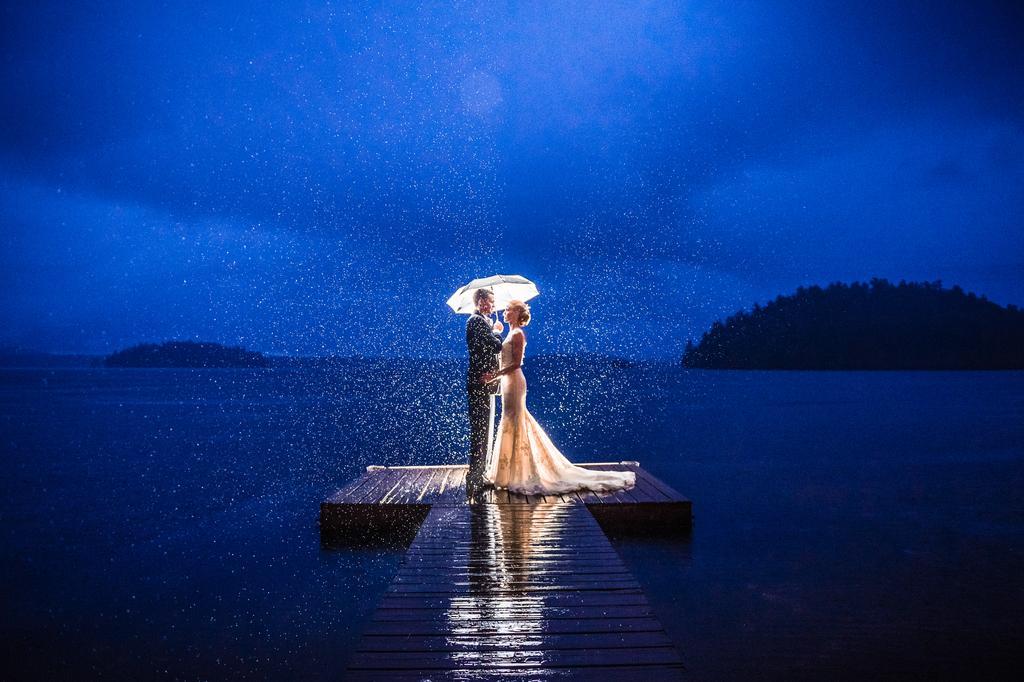Can you describe this image briefly? In the background we can see a clear blue sky, it's dark and we can see hills and the thicket. We can see a woman and a man are standing on a wooden platform. A man is holding an umbrella. We can see the water. 